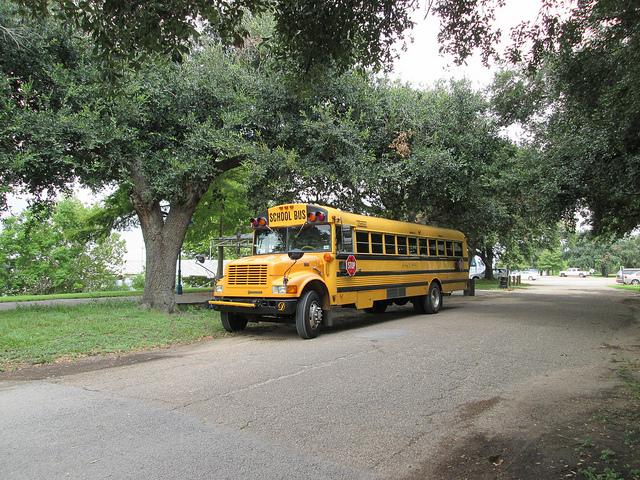What kind of bus is this?
Answer briefly. School. Are there lights behind the photographer?
Answer briefly. No. Who is probably riding this bus?
Keep it brief. Children. How many school buses are shown?
Answer briefly. 1. What color is the bus?
Give a very brief answer. Yellow. 